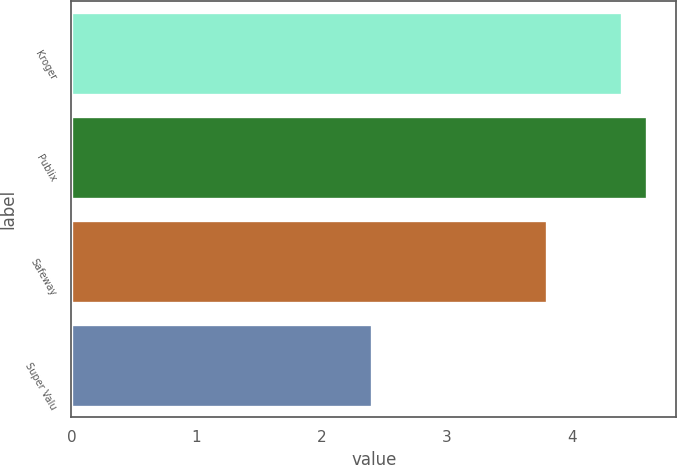Convert chart to OTSL. <chart><loc_0><loc_0><loc_500><loc_500><bar_chart><fcel>Kroger<fcel>Publix<fcel>Safeway<fcel>Super Valu<nl><fcel>4.4<fcel>4.6<fcel>3.8<fcel>2.4<nl></chart> 